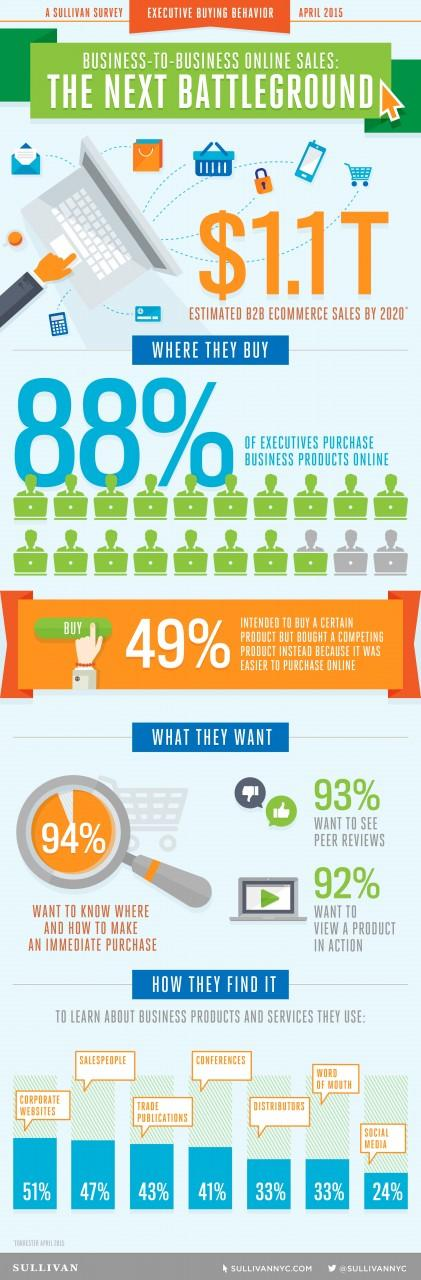Give some essential details in this illustration. According to a Sullivan survey of executive buying behavior in April 2015, a significant percentage of executives, specifically 8%, do not want to view a product in action. According to a survey conducted by Sullivan in April 2015 on executive buying behavior, 24% of executives use social media to learn about business products and services. According to a Sullivan survey conducted in April 2015, only 12% of executives do not purchase business products online. According to a Sullivan survey of executive buying behavior in April 2015, 41% of executives use conferences to learn about business products and services. According to a Sullivan survey of executive buying behavior in April 2015, corporate websites are the preferred method for learning about business products and services among most executives. 